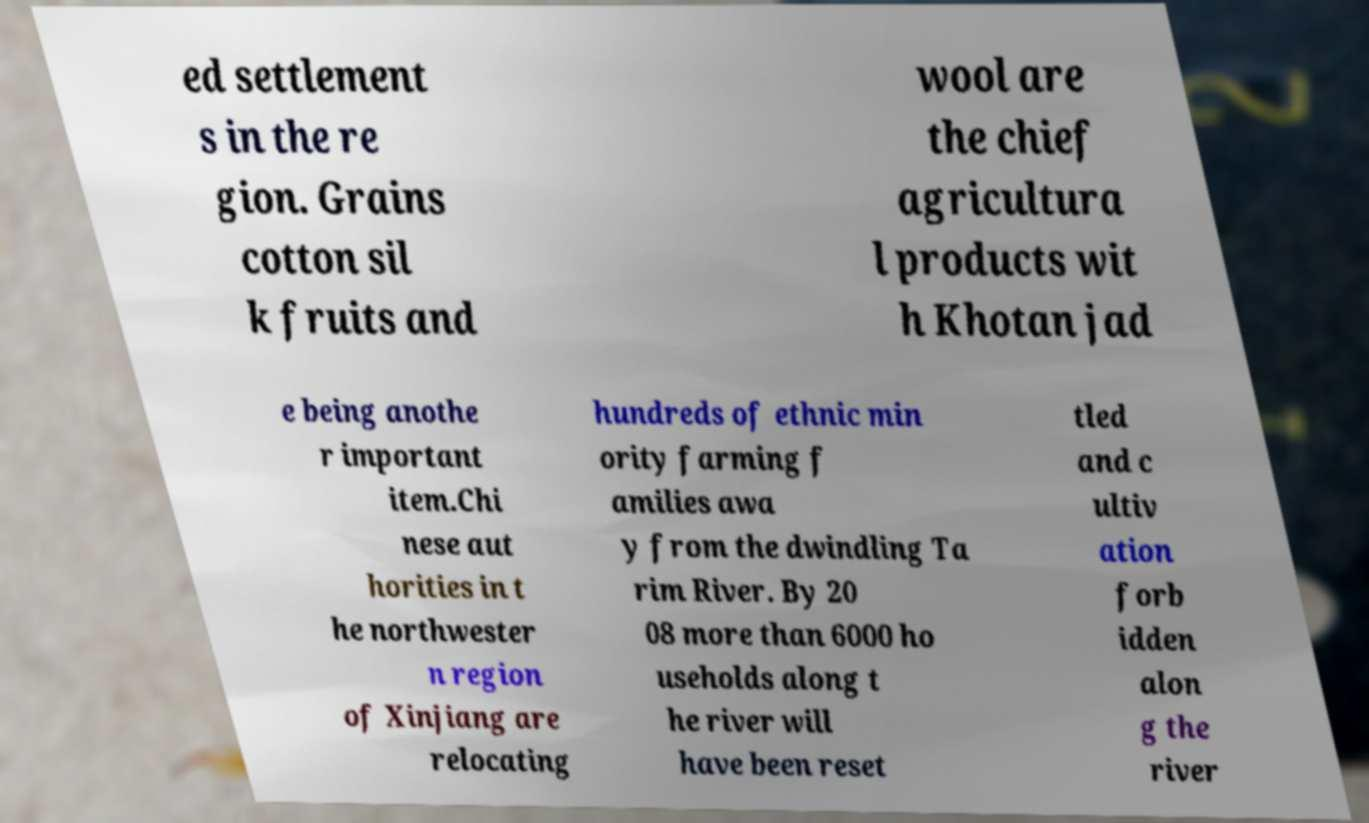Can you read and provide the text displayed in the image?This photo seems to have some interesting text. Can you extract and type it out for me? ed settlement s in the re gion. Grains cotton sil k fruits and wool are the chief agricultura l products wit h Khotan jad e being anothe r important item.Chi nese aut horities in t he northwester n region of Xinjiang are relocating hundreds of ethnic min ority farming f amilies awa y from the dwindling Ta rim River. By 20 08 more than 6000 ho useholds along t he river will have been reset tled and c ultiv ation forb idden alon g the river 